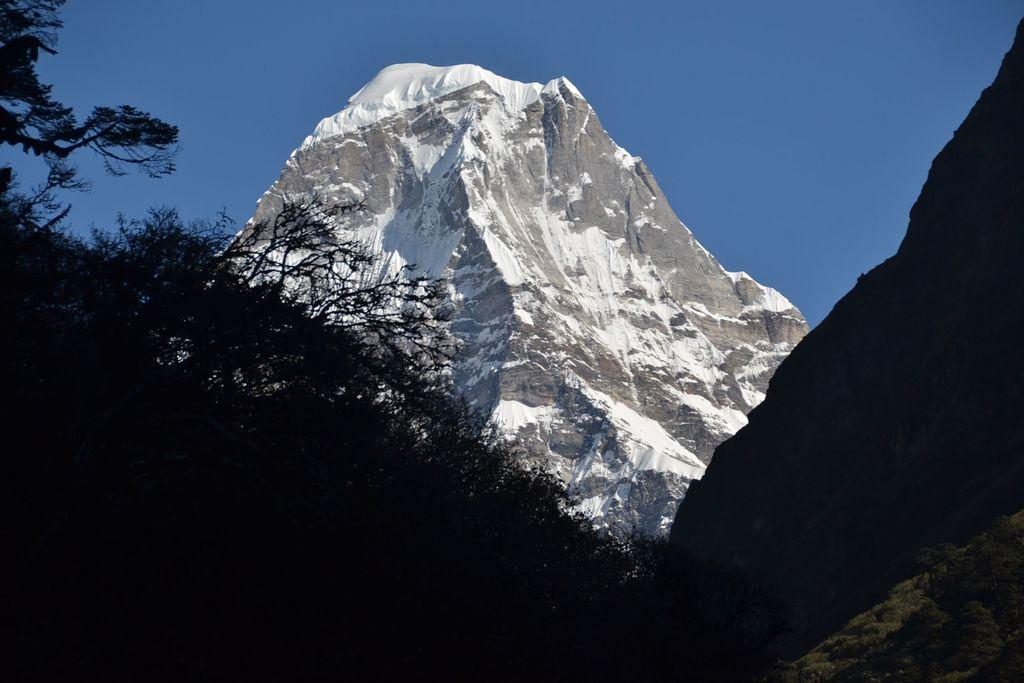What type of natural features can be seen in the image? There are trees and a mountain in the image. What is the condition of the mountain in the image? The mountain has snow on it. What is visible in the background of the image? There is a sky visible in the background of the image. What type of memory can be seen in the image? There is no memory present in the image; it features natural elements such as trees, a mountain, and a sky. What type of seed is growing on the mountain in the image? There is no seed growing on the mountain in the image; it has snow on it. 